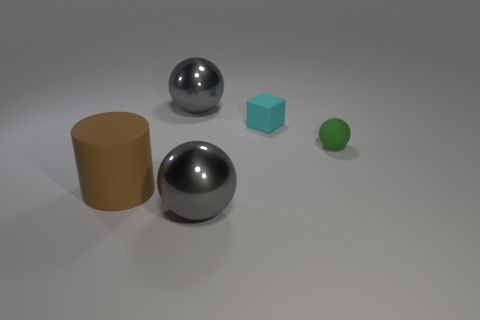Subtract all tiny rubber balls. How many balls are left? 2 Add 3 tiny green blocks. How many objects exist? 8 Subtract all cylinders. How many objects are left? 4 Add 2 large spheres. How many large spheres are left? 4 Add 1 cyan rubber cylinders. How many cyan rubber cylinders exist? 1 Subtract 0 cyan spheres. How many objects are left? 5 Subtract all red rubber things. Subtract all rubber spheres. How many objects are left? 4 